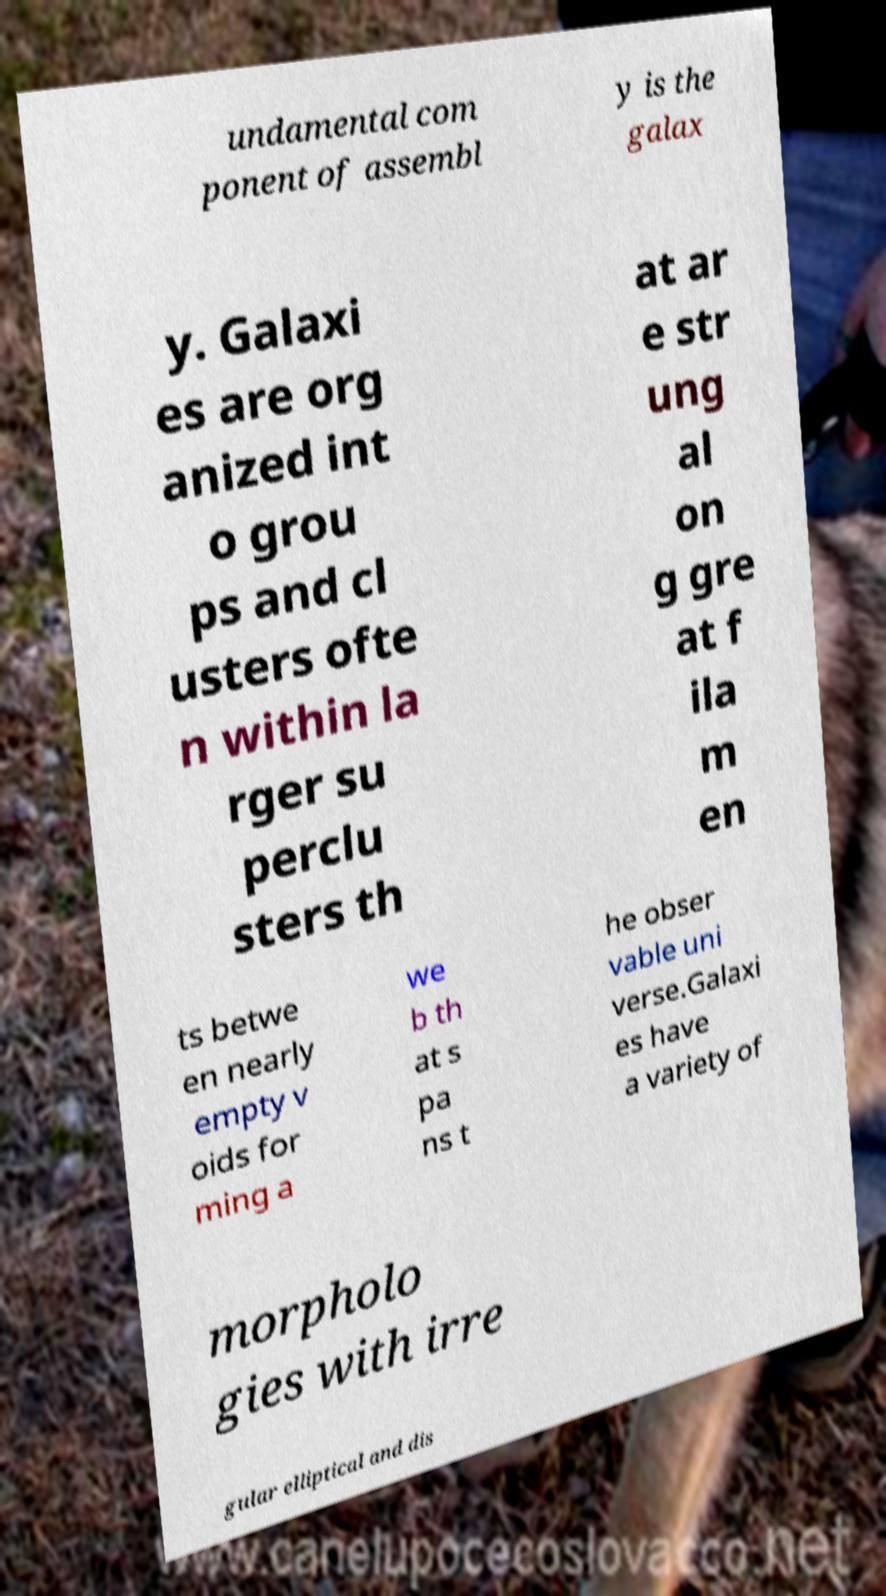There's text embedded in this image that I need extracted. Can you transcribe it verbatim? undamental com ponent of assembl y is the galax y. Galaxi es are org anized int o grou ps and cl usters ofte n within la rger su perclu sters th at ar e str ung al on g gre at f ila m en ts betwe en nearly empty v oids for ming a we b th at s pa ns t he obser vable uni verse.Galaxi es have a variety of morpholo gies with irre gular elliptical and dis 